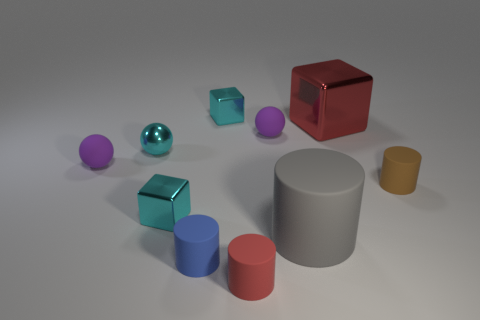There is a brown cylinder; is it the same size as the red object in front of the gray object?
Provide a short and direct response. Yes. There is a big gray object that is in front of the small cyan object that is in front of the tiny matte cylinder on the right side of the gray object; what is its shape?
Keep it short and to the point. Cylinder. Is the number of small blue matte cylinders less than the number of tiny green metallic objects?
Provide a short and direct response. No. There is a big gray rubber cylinder; are there any large shiny objects in front of it?
Your answer should be very brief. No. What shape is the cyan object that is behind the small brown thing and in front of the big red block?
Provide a short and direct response. Sphere. Is there a cyan object that has the same shape as the tiny red matte thing?
Give a very brief answer. No. Does the cyan shiny block behind the red block have the same size as the sphere behind the cyan sphere?
Your answer should be compact. Yes. Is the number of large brown rubber spheres greater than the number of gray rubber objects?
Ensure brevity in your answer.  No. How many large gray things are the same material as the big red object?
Offer a terse response. 0. Is the brown thing the same shape as the big gray thing?
Offer a very short reply. Yes. 